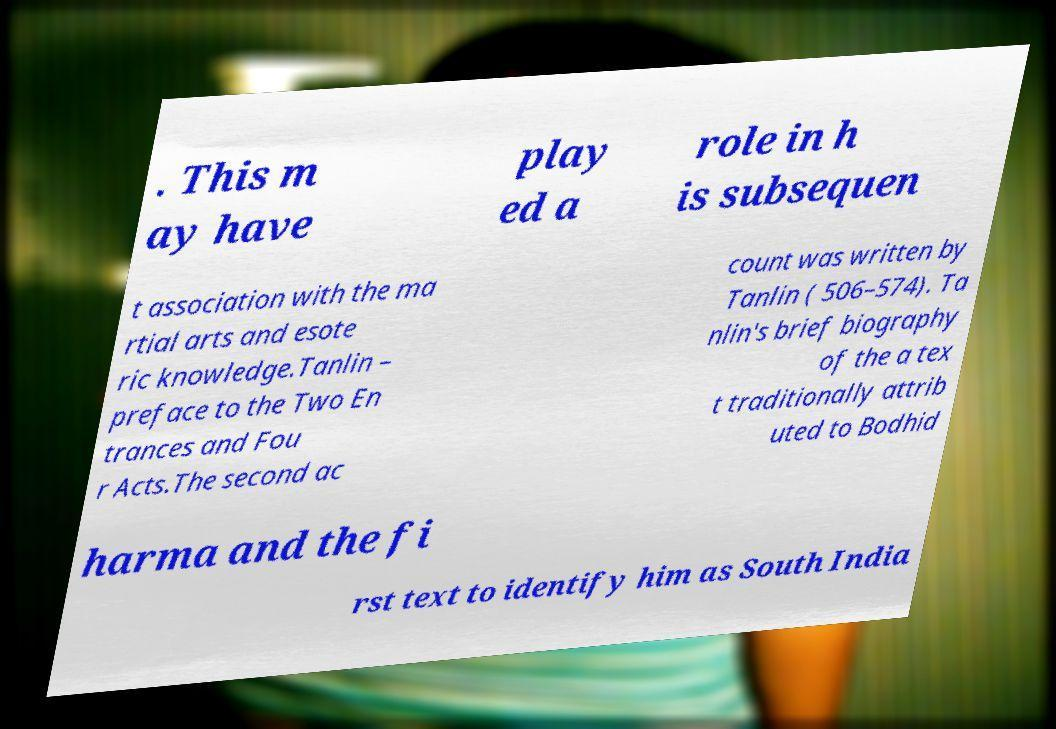There's text embedded in this image that I need extracted. Can you transcribe it verbatim? . This m ay have play ed a role in h is subsequen t association with the ma rtial arts and esote ric knowledge.Tanlin – preface to the Two En trances and Fou r Acts.The second ac count was written by Tanlin ( 506–574). Ta nlin's brief biography of the a tex t traditionally attrib uted to Bodhid harma and the fi rst text to identify him as South India 